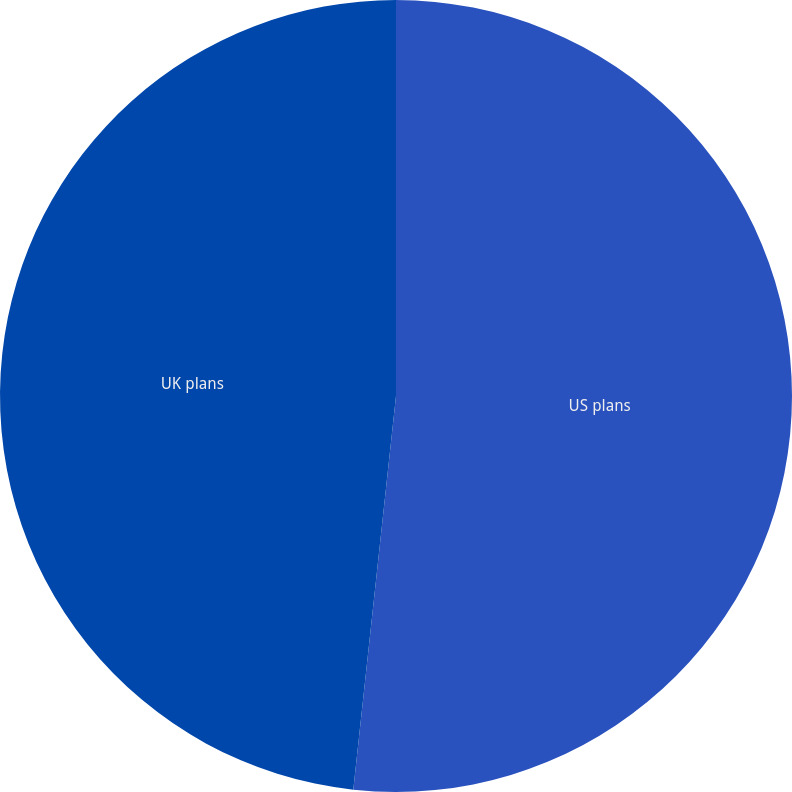<chart> <loc_0><loc_0><loc_500><loc_500><pie_chart><fcel>US plans<fcel>UK plans<nl><fcel>51.72%<fcel>48.28%<nl></chart> 